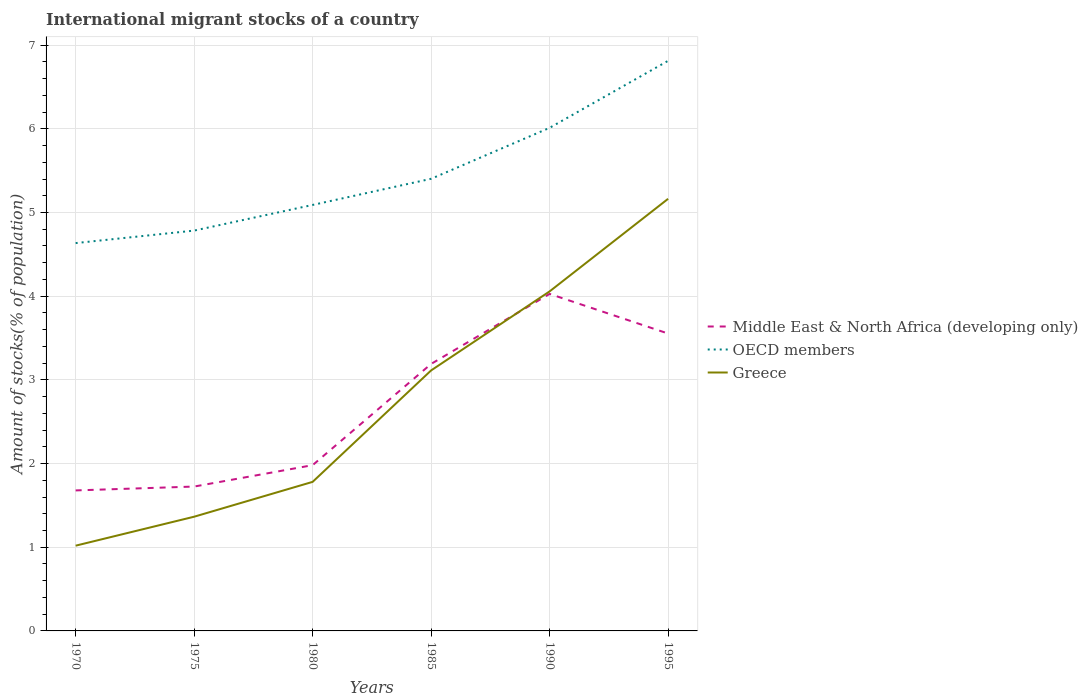Does the line corresponding to OECD members intersect with the line corresponding to Greece?
Your answer should be very brief. No. Is the number of lines equal to the number of legend labels?
Ensure brevity in your answer.  Yes. Across all years, what is the maximum amount of stocks in in OECD members?
Your response must be concise. 4.63. In which year was the amount of stocks in in Middle East & North Africa (developing only) maximum?
Your answer should be compact. 1970. What is the total amount of stocks in in Greece in the graph?
Provide a succinct answer. -0.94. What is the difference between the highest and the second highest amount of stocks in in OECD members?
Provide a succinct answer. 2.18. Is the amount of stocks in in OECD members strictly greater than the amount of stocks in in Middle East & North Africa (developing only) over the years?
Ensure brevity in your answer.  No. Where does the legend appear in the graph?
Provide a short and direct response. Center right. How many legend labels are there?
Your answer should be compact. 3. How are the legend labels stacked?
Provide a succinct answer. Vertical. What is the title of the graph?
Offer a terse response. International migrant stocks of a country. What is the label or title of the X-axis?
Keep it short and to the point. Years. What is the label or title of the Y-axis?
Your response must be concise. Amount of stocks(% of population). What is the Amount of stocks(% of population) in Middle East & North Africa (developing only) in 1970?
Your answer should be compact. 1.68. What is the Amount of stocks(% of population) of OECD members in 1970?
Ensure brevity in your answer.  4.63. What is the Amount of stocks(% of population) in Greece in 1970?
Your response must be concise. 1.02. What is the Amount of stocks(% of population) of Middle East & North Africa (developing only) in 1975?
Your answer should be very brief. 1.73. What is the Amount of stocks(% of population) of OECD members in 1975?
Provide a short and direct response. 4.78. What is the Amount of stocks(% of population) of Greece in 1975?
Offer a very short reply. 1.36. What is the Amount of stocks(% of population) in Middle East & North Africa (developing only) in 1980?
Ensure brevity in your answer.  1.98. What is the Amount of stocks(% of population) in OECD members in 1980?
Your answer should be compact. 5.09. What is the Amount of stocks(% of population) in Greece in 1980?
Keep it short and to the point. 1.78. What is the Amount of stocks(% of population) in Middle East & North Africa (developing only) in 1985?
Keep it short and to the point. 3.19. What is the Amount of stocks(% of population) of OECD members in 1985?
Keep it short and to the point. 5.4. What is the Amount of stocks(% of population) in Greece in 1985?
Offer a terse response. 3.11. What is the Amount of stocks(% of population) in Middle East & North Africa (developing only) in 1990?
Make the answer very short. 4.03. What is the Amount of stocks(% of population) of OECD members in 1990?
Make the answer very short. 6.01. What is the Amount of stocks(% of population) in Greece in 1990?
Ensure brevity in your answer.  4.06. What is the Amount of stocks(% of population) of Middle East & North Africa (developing only) in 1995?
Provide a succinct answer. 3.55. What is the Amount of stocks(% of population) of OECD members in 1995?
Provide a short and direct response. 6.81. What is the Amount of stocks(% of population) in Greece in 1995?
Keep it short and to the point. 5.16. Across all years, what is the maximum Amount of stocks(% of population) in Middle East & North Africa (developing only)?
Offer a terse response. 4.03. Across all years, what is the maximum Amount of stocks(% of population) in OECD members?
Offer a very short reply. 6.81. Across all years, what is the maximum Amount of stocks(% of population) of Greece?
Your answer should be very brief. 5.16. Across all years, what is the minimum Amount of stocks(% of population) of Middle East & North Africa (developing only)?
Your answer should be compact. 1.68. Across all years, what is the minimum Amount of stocks(% of population) of OECD members?
Provide a succinct answer. 4.63. Across all years, what is the minimum Amount of stocks(% of population) in Greece?
Give a very brief answer. 1.02. What is the total Amount of stocks(% of population) of Middle East & North Africa (developing only) in the graph?
Offer a very short reply. 16.16. What is the total Amount of stocks(% of population) of OECD members in the graph?
Offer a very short reply. 32.74. What is the total Amount of stocks(% of population) of Greece in the graph?
Make the answer very short. 16.5. What is the difference between the Amount of stocks(% of population) in Middle East & North Africa (developing only) in 1970 and that in 1975?
Your response must be concise. -0.05. What is the difference between the Amount of stocks(% of population) in OECD members in 1970 and that in 1975?
Your response must be concise. -0.15. What is the difference between the Amount of stocks(% of population) in Greece in 1970 and that in 1975?
Your answer should be compact. -0.35. What is the difference between the Amount of stocks(% of population) of Middle East & North Africa (developing only) in 1970 and that in 1980?
Make the answer very short. -0.3. What is the difference between the Amount of stocks(% of population) in OECD members in 1970 and that in 1980?
Provide a succinct answer. -0.46. What is the difference between the Amount of stocks(% of population) in Greece in 1970 and that in 1980?
Your response must be concise. -0.76. What is the difference between the Amount of stocks(% of population) of Middle East & North Africa (developing only) in 1970 and that in 1985?
Provide a succinct answer. -1.51. What is the difference between the Amount of stocks(% of population) in OECD members in 1970 and that in 1985?
Your response must be concise. -0.77. What is the difference between the Amount of stocks(% of population) in Greece in 1970 and that in 1985?
Your answer should be very brief. -2.09. What is the difference between the Amount of stocks(% of population) in Middle East & North Africa (developing only) in 1970 and that in 1990?
Offer a terse response. -2.35. What is the difference between the Amount of stocks(% of population) in OECD members in 1970 and that in 1990?
Your answer should be very brief. -1.38. What is the difference between the Amount of stocks(% of population) in Greece in 1970 and that in 1990?
Keep it short and to the point. -3.04. What is the difference between the Amount of stocks(% of population) in Middle East & North Africa (developing only) in 1970 and that in 1995?
Keep it short and to the point. -1.87. What is the difference between the Amount of stocks(% of population) in OECD members in 1970 and that in 1995?
Offer a very short reply. -2.18. What is the difference between the Amount of stocks(% of population) of Greece in 1970 and that in 1995?
Give a very brief answer. -4.14. What is the difference between the Amount of stocks(% of population) of Middle East & North Africa (developing only) in 1975 and that in 1980?
Make the answer very short. -0.26. What is the difference between the Amount of stocks(% of population) of OECD members in 1975 and that in 1980?
Provide a short and direct response. -0.31. What is the difference between the Amount of stocks(% of population) of Greece in 1975 and that in 1980?
Your answer should be very brief. -0.42. What is the difference between the Amount of stocks(% of population) in Middle East & North Africa (developing only) in 1975 and that in 1985?
Keep it short and to the point. -1.47. What is the difference between the Amount of stocks(% of population) of OECD members in 1975 and that in 1985?
Keep it short and to the point. -0.62. What is the difference between the Amount of stocks(% of population) of Greece in 1975 and that in 1985?
Make the answer very short. -1.75. What is the difference between the Amount of stocks(% of population) in Middle East & North Africa (developing only) in 1975 and that in 1990?
Your answer should be very brief. -2.3. What is the difference between the Amount of stocks(% of population) in OECD members in 1975 and that in 1990?
Offer a terse response. -1.23. What is the difference between the Amount of stocks(% of population) of Greece in 1975 and that in 1990?
Offer a very short reply. -2.69. What is the difference between the Amount of stocks(% of population) of Middle East & North Africa (developing only) in 1975 and that in 1995?
Give a very brief answer. -1.83. What is the difference between the Amount of stocks(% of population) in OECD members in 1975 and that in 1995?
Your response must be concise. -2.03. What is the difference between the Amount of stocks(% of population) of Greece in 1975 and that in 1995?
Keep it short and to the point. -3.8. What is the difference between the Amount of stocks(% of population) in Middle East & North Africa (developing only) in 1980 and that in 1985?
Provide a succinct answer. -1.21. What is the difference between the Amount of stocks(% of population) in OECD members in 1980 and that in 1985?
Provide a short and direct response. -0.31. What is the difference between the Amount of stocks(% of population) of Greece in 1980 and that in 1985?
Provide a short and direct response. -1.33. What is the difference between the Amount of stocks(% of population) in Middle East & North Africa (developing only) in 1980 and that in 1990?
Provide a succinct answer. -2.05. What is the difference between the Amount of stocks(% of population) of OECD members in 1980 and that in 1990?
Your answer should be very brief. -0.92. What is the difference between the Amount of stocks(% of population) in Greece in 1980 and that in 1990?
Give a very brief answer. -2.28. What is the difference between the Amount of stocks(% of population) of Middle East & North Africa (developing only) in 1980 and that in 1995?
Provide a short and direct response. -1.57. What is the difference between the Amount of stocks(% of population) in OECD members in 1980 and that in 1995?
Offer a terse response. -1.72. What is the difference between the Amount of stocks(% of population) of Greece in 1980 and that in 1995?
Your answer should be very brief. -3.38. What is the difference between the Amount of stocks(% of population) of Middle East & North Africa (developing only) in 1985 and that in 1990?
Give a very brief answer. -0.84. What is the difference between the Amount of stocks(% of population) in OECD members in 1985 and that in 1990?
Keep it short and to the point. -0.61. What is the difference between the Amount of stocks(% of population) in Greece in 1985 and that in 1990?
Provide a short and direct response. -0.94. What is the difference between the Amount of stocks(% of population) in Middle East & North Africa (developing only) in 1985 and that in 1995?
Your answer should be compact. -0.36. What is the difference between the Amount of stocks(% of population) of OECD members in 1985 and that in 1995?
Your answer should be very brief. -1.41. What is the difference between the Amount of stocks(% of population) in Greece in 1985 and that in 1995?
Provide a short and direct response. -2.05. What is the difference between the Amount of stocks(% of population) in Middle East & North Africa (developing only) in 1990 and that in 1995?
Provide a short and direct response. 0.47. What is the difference between the Amount of stocks(% of population) in OECD members in 1990 and that in 1995?
Offer a very short reply. -0.8. What is the difference between the Amount of stocks(% of population) in Greece in 1990 and that in 1995?
Your answer should be compact. -1.11. What is the difference between the Amount of stocks(% of population) of Middle East & North Africa (developing only) in 1970 and the Amount of stocks(% of population) of OECD members in 1975?
Ensure brevity in your answer.  -3.1. What is the difference between the Amount of stocks(% of population) of Middle East & North Africa (developing only) in 1970 and the Amount of stocks(% of population) of Greece in 1975?
Offer a terse response. 0.31. What is the difference between the Amount of stocks(% of population) in OECD members in 1970 and the Amount of stocks(% of population) in Greece in 1975?
Your response must be concise. 3.27. What is the difference between the Amount of stocks(% of population) of Middle East & North Africa (developing only) in 1970 and the Amount of stocks(% of population) of OECD members in 1980?
Make the answer very short. -3.41. What is the difference between the Amount of stocks(% of population) of Middle East & North Africa (developing only) in 1970 and the Amount of stocks(% of population) of Greece in 1980?
Give a very brief answer. -0.1. What is the difference between the Amount of stocks(% of population) in OECD members in 1970 and the Amount of stocks(% of population) in Greece in 1980?
Keep it short and to the point. 2.85. What is the difference between the Amount of stocks(% of population) in Middle East & North Africa (developing only) in 1970 and the Amount of stocks(% of population) in OECD members in 1985?
Keep it short and to the point. -3.72. What is the difference between the Amount of stocks(% of population) of Middle East & North Africa (developing only) in 1970 and the Amount of stocks(% of population) of Greece in 1985?
Offer a very short reply. -1.43. What is the difference between the Amount of stocks(% of population) in OECD members in 1970 and the Amount of stocks(% of population) in Greece in 1985?
Provide a short and direct response. 1.52. What is the difference between the Amount of stocks(% of population) of Middle East & North Africa (developing only) in 1970 and the Amount of stocks(% of population) of OECD members in 1990?
Your answer should be very brief. -4.33. What is the difference between the Amount of stocks(% of population) in Middle East & North Africa (developing only) in 1970 and the Amount of stocks(% of population) in Greece in 1990?
Keep it short and to the point. -2.38. What is the difference between the Amount of stocks(% of population) in OECD members in 1970 and the Amount of stocks(% of population) in Greece in 1990?
Give a very brief answer. 0.58. What is the difference between the Amount of stocks(% of population) of Middle East & North Africa (developing only) in 1970 and the Amount of stocks(% of population) of OECD members in 1995?
Make the answer very short. -5.13. What is the difference between the Amount of stocks(% of population) in Middle East & North Africa (developing only) in 1970 and the Amount of stocks(% of population) in Greece in 1995?
Make the answer very short. -3.48. What is the difference between the Amount of stocks(% of population) in OECD members in 1970 and the Amount of stocks(% of population) in Greece in 1995?
Make the answer very short. -0.53. What is the difference between the Amount of stocks(% of population) of Middle East & North Africa (developing only) in 1975 and the Amount of stocks(% of population) of OECD members in 1980?
Your answer should be very brief. -3.37. What is the difference between the Amount of stocks(% of population) in Middle East & North Africa (developing only) in 1975 and the Amount of stocks(% of population) in Greece in 1980?
Keep it short and to the point. -0.06. What is the difference between the Amount of stocks(% of population) of OECD members in 1975 and the Amount of stocks(% of population) of Greece in 1980?
Your response must be concise. 3. What is the difference between the Amount of stocks(% of population) in Middle East & North Africa (developing only) in 1975 and the Amount of stocks(% of population) in OECD members in 1985?
Give a very brief answer. -3.68. What is the difference between the Amount of stocks(% of population) in Middle East & North Africa (developing only) in 1975 and the Amount of stocks(% of population) in Greece in 1985?
Provide a short and direct response. -1.39. What is the difference between the Amount of stocks(% of population) of OECD members in 1975 and the Amount of stocks(% of population) of Greece in 1985?
Your answer should be very brief. 1.67. What is the difference between the Amount of stocks(% of population) of Middle East & North Africa (developing only) in 1975 and the Amount of stocks(% of population) of OECD members in 1990?
Your answer should be compact. -4.29. What is the difference between the Amount of stocks(% of population) of Middle East & North Africa (developing only) in 1975 and the Amount of stocks(% of population) of Greece in 1990?
Offer a very short reply. -2.33. What is the difference between the Amount of stocks(% of population) in OECD members in 1975 and the Amount of stocks(% of population) in Greece in 1990?
Ensure brevity in your answer.  0.73. What is the difference between the Amount of stocks(% of population) of Middle East & North Africa (developing only) in 1975 and the Amount of stocks(% of population) of OECD members in 1995?
Give a very brief answer. -5.09. What is the difference between the Amount of stocks(% of population) of Middle East & North Africa (developing only) in 1975 and the Amount of stocks(% of population) of Greece in 1995?
Provide a succinct answer. -3.44. What is the difference between the Amount of stocks(% of population) in OECD members in 1975 and the Amount of stocks(% of population) in Greece in 1995?
Ensure brevity in your answer.  -0.38. What is the difference between the Amount of stocks(% of population) in Middle East & North Africa (developing only) in 1980 and the Amount of stocks(% of population) in OECD members in 1985?
Provide a short and direct response. -3.42. What is the difference between the Amount of stocks(% of population) in Middle East & North Africa (developing only) in 1980 and the Amount of stocks(% of population) in Greece in 1985?
Your response must be concise. -1.13. What is the difference between the Amount of stocks(% of population) in OECD members in 1980 and the Amount of stocks(% of population) in Greece in 1985?
Your answer should be compact. 1.98. What is the difference between the Amount of stocks(% of population) in Middle East & North Africa (developing only) in 1980 and the Amount of stocks(% of population) in OECD members in 1990?
Give a very brief answer. -4.03. What is the difference between the Amount of stocks(% of population) in Middle East & North Africa (developing only) in 1980 and the Amount of stocks(% of population) in Greece in 1990?
Keep it short and to the point. -2.08. What is the difference between the Amount of stocks(% of population) in OECD members in 1980 and the Amount of stocks(% of population) in Greece in 1990?
Provide a short and direct response. 1.03. What is the difference between the Amount of stocks(% of population) of Middle East & North Africa (developing only) in 1980 and the Amount of stocks(% of population) of OECD members in 1995?
Your answer should be very brief. -4.83. What is the difference between the Amount of stocks(% of population) in Middle East & North Africa (developing only) in 1980 and the Amount of stocks(% of population) in Greece in 1995?
Offer a terse response. -3.18. What is the difference between the Amount of stocks(% of population) in OECD members in 1980 and the Amount of stocks(% of population) in Greece in 1995?
Provide a succinct answer. -0.07. What is the difference between the Amount of stocks(% of population) in Middle East & North Africa (developing only) in 1985 and the Amount of stocks(% of population) in OECD members in 1990?
Your answer should be compact. -2.82. What is the difference between the Amount of stocks(% of population) of Middle East & North Africa (developing only) in 1985 and the Amount of stocks(% of population) of Greece in 1990?
Your response must be concise. -0.87. What is the difference between the Amount of stocks(% of population) in OECD members in 1985 and the Amount of stocks(% of population) in Greece in 1990?
Your answer should be compact. 1.35. What is the difference between the Amount of stocks(% of population) in Middle East & North Africa (developing only) in 1985 and the Amount of stocks(% of population) in OECD members in 1995?
Your response must be concise. -3.62. What is the difference between the Amount of stocks(% of population) in Middle East & North Africa (developing only) in 1985 and the Amount of stocks(% of population) in Greece in 1995?
Offer a terse response. -1.97. What is the difference between the Amount of stocks(% of population) of OECD members in 1985 and the Amount of stocks(% of population) of Greece in 1995?
Your response must be concise. 0.24. What is the difference between the Amount of stocks(% of population) of Middle East & North Africa (developing only) in 1990 and the Amount of stocks(% of population) of OECD members in 1995?
Keep it short and to the point. -2.79. What is the difference between the Amount of stocks(% of population) of Middle East & North Africa (developing only) in 1990 and the Amount of stocks(% of population) of Greece in 1995?
Your answer should be very brief. -1.14. What is the difference between the Amount of stocks(% of population) of OECD members in 1990 and the Amount of stocks(% of population) of Greece in 1995?
Your answer should be very brief. 0.85. What is the average Amount of stocks(% of population) of Middle East & North Africa (developing only) per year?
Offer a very short reply. 2.69. What is the average Amount of stocks(% of population) in OECD members per year?
Keep it short and to the point. 5.46. What is the average Amount of stocks(% of population) in Greece per year?
Provide a short and direct response. 2.75. In the year 1970, what is the difference between the Amount of stocks(% of population) in Middle East & North Africa (developing only) and Amount of stocks(% of population) in OECD members?
Your answer should be very brief. -2.96. In the year 1970, what is the difference between the Amount of stocks(% of population) in Middle East & North Africa (developing only) and Amount of stocks(% of population) in Greece?
Offer a very short reply. 0.66. In the year 1970, what is the difference between the Amount of stocks(% of population) of OECD members and Amount of stocks(% of population) of Greece?
Offer a very short reply. 3.62. In the year 1975, what is the difference between the Amount of stocks(% of population) of Middle East & North Africa (developing only) and Amount of stocks(% of population) of OECD members?
Ensure brevity in your answer.  -3.06. In the year 1975, what is the difference between the Amount of stocks(% of population) in Middle East & North Africa (developing only) and Amount of stocks(% of population) in Greece?
Your answer should be very brief. 0.36. In the year 1975, what is the difference between the Amount of stocks(% of population) in OECD members and Amount of stocks(% of population) in Greece?
Make the answer very short. 3.42. In the year 1980, what is the difference between the Amount of stocks(% of population) of Middle East & North Africa (developing only) and Amount of stocks(% of population) of OECD members?
Your response must be concise. -3.11. In the year 1980, what is the difference between the Amount of stocks(% of population) in Middle East & North Africa (developing only) and Amount of stocks(% of population) in Greece?
Your response must be concise. 0.2. In the year 1980, what is the difference between the Amount of stocks(% of population) in OECD members and Amount of stocks(% of population) in Greece?
Provide a succinct answer. 3.31. In the year 1985, what is the difference between the Amount of stocks(% of population) of Middle East & North Africa (developing only) and Amount of stocks(% of population) of OECD members?
Your answer should be very brief. -2.21. In the year 1985, what is the difference between the Amount of stocks(% of population) in Middle East & North Africa (developing only) and Amount of stocks(% of population) in Greece?
Keep it short and to the point. 0.08. In the year 1985, what is the difference between the Amount of stocks(% of population) in OECD members and Amount of stocks(% of population) in Greece?
Provide a short and direct response. 2.29. In the year 1990, what is the difference between the Amount of stocks(% of population) in Middle East & North Africa (developing only) and Amount of stocks(% of population) in OECD members?
Provide a succinct answer. -1.98. In the year 1990, what is the difference between the Amount of stocks(% of population) in Middle East & North Africa (developing only) and Amount of stocks(% of population) in Greece?
Give a very brief answer. -0.03. In the year 1990, what is the difference between the Amount of stocks(% of population) in OECD members and Amount of stocks(% of population) in Greece?
Your response must be concise. 1.95. In the year 1995, what is the difference between the Amount of stocks(% of population) of Middle East & North Africa (developing only) and Amount of stocks(% of population) of OECD members?
Offer a very short reply. -3.26. In the year 1995, what is the difference between the Amount of stocks(% of population) in Middle East & North Africa (developing only) and Amount of stocks(% of population) in Greece?
Your answer should be compact. -1.61. In the year 1995, what is the difference between the Amount of stocks(% of population) of OECD members and Amount of stocks(% of population) of Greece?
Offer a terse response. 1.65. What is the ratio of the Amount of stocks(% of population) in Middle East & North Africa (developing only) in 1970 to that in 1975?
Your response must be concise. 0.97. What is the ratio of the Amount of stocks(% of population) in OECD members in 1970 to that in 1975?
Offer a terse response. 0.97. What is the ratio of the Amount of stocks(% of population) of Greece in 1970 to that in 1975?
Your answer should be very brief. 0.75. What is the ratio of the Amount of stocks(% of population) of Middle East & North Africa (developing only) in 1970 to that in 1980?
Offer a very short reply. 0.85. What is the ratio of the Amount of stocks(% of population) in OECD members in 1970 to that in 1980?
Make the answer very short. 0.91. What is the ratio of the Amount of stocks(% of population) of Greece in 1970 to that in 1980?
Provide a short and direct response. 0.57. What is the ratio of the Amount of stocks(% of population) in Middle East & North Africa (developing only) in 1970 to that in 1985?
Ensure brevity in your answer.  0.53. What is the ratio of the Amount of stocks(% of population) of OECD members in 1970 to that in 1985?
Your response must be concise. 0.86. What is the ratio of the Amount of stocks(% of population) of Greece in 1970 to that in 1985?
Provide a short and direct response. 0.33. What is the ratio of the Amount of stocks(% of population) in Middle East & North Africa (developing only) in 1970 to that in 1990?
Your answer should be compact. 0.42. What is the ratio of the Amount of stocks(% of population) of OECD members in 1970 to that in 1990?
Provide a short and direct response. 0.77. What is the ratio of the Amount of stocks(% of population) in Greece in 1970 to that in 1990?
Offer a terse response. 0.25. What is the ratio of the Amount of stocks(% of population) of Middle East & North Africa (developing only) in 1970 to that in 1995?
Provide a short and direct response. 0.47. What is the ratio of the Amount of stocks(% of population) of OECD members in 1970 to that in 1995?
Make the answer very short. 0.68. What is the ratio of the Amount of stocks(% of population) in Greece in 1970 to that in 1995?
Your response must be concise. 0.2. What is the ratio of the Amount of stocks(% of population) in Middle East & North Africa (developing only) in 1975 to that in 1980?
Ensure brevity in your answer.  0.87. What is the ratio of the Amount of stocks(% of population) of OECD members in 1975 to that in 1980?
Keep it short and to the point. 0.94. What is the ratio of the Amount of stocks(% of population) in Greece in 1975 to that in 1980?
Keep it short and to the point. 0.77. What is the ratio of the Amount of stocks(% of population) in Middle East & North Africa (developing only) in 1975 to that in 1985?
Ensure brevity in your answer.  0.54. What is the ratio of the Amount of stocks(% of population) of OECD members in 1975 to that in 1985?
Make the answer very short. 0.89. What is the ratio of the Amount of stocks(% of population) of Greece in 1975 to that in 1985?
Provide a succinct answer. 0.44. What is the ratio of the Amount of stocks(% of population) of Middle East & North Africa (developing only) in 1975 to that in 1990?
Provide a short and direct response. 0.43. What is the ratio of the Amount of stocks(% of population) of OECD members in 1975 to that in 1990?
Keep it short and to the point. 0.8. What is the ratio of the Amount of stocks(% of population) of Greece in 1975 to that in 1990?
Make the answer very short. 0.34. What is the ratio of the Amount of stocks(% of population) of Middle East & North Africa (developing only) in 1975 to that in 1995?
Your answer should be very brief. 0.49. What is the ratio of the Amount of stocks(% of population) in OECD members in 1975 to that in 1995?
Make the answer very short. 0.7. What is the ratio of the Amount of stocks(% of population) in Greece in 1975 to that in 1995?
Give a very brief answer. 0.26. What is the ratio of the Amount of stocks(% of population) of Middle East & North Africa (developing only) in 1980 to that in 1985?
Your answer should be very brief. 0.62. What is the ratio of the Amount of stocks(% of population) of OECD members in 1980 to that in 1985?
Make the answer very short. 0.94. What is the ratio of the Amount of stocks(% of population) in Greece in 1980 to that in 1985?
Provide a succinct answer. 0.57. What is the ratio of the Amount of stocks(% of population) of Middle East & North Africa (developing only) in 1980 to that in 1990?
Keep it short and to the point. 0.49. What is the ratio of the Amount of stocks(% of population) of OECD members in 1980 to that in 1990?
Your response must be concise. 0.85. What is the ratio of the Amount of stocks(% of population) in Greece in 1980 to that in 1990?
Your answer should be compact. 0.44. What is the ratio of the Amount of stocks(% of population) in Middle East & North Africa (developing only) in 1980 to that in 1995?
Your answer should be compact. 0.56. What is the ratio of the Amount of stocks(% of population) in OECD members in 1980 to that in 1995?
Your response must be concise. 0.75. What is the ratio of the Amount of stocks(% of population) of Greece in 1980 to that in 1995?
Provide a succinct answer. 0.34. What is the ratio of the Amount of stocks(% of population) in Middle East & North Africa (developing only) in 1985 to that in 1990?
Give a very brief answer. 0.79. What is the ratio of the Amount of stocks(% of population) in OECD members in 1985 to that in 1990?
Offer a very short reply. 0.9. What is the ratio of the Amount of stocks(% of population) in Greece in 1985 to that in 1990?
Your answer should be very brief. 0.77. What is the ratio of the Amount of stocks(% of population) in Middle East & North Africa (developing only) in 1985 to that in 1995?
Provide a succinct answer. 0.9. What is the ratio of the Amount of stocks(% of population) in OECD members in 1985 to that in 1995?
Provide a succinct answer. 0.79. What is the ratio of the Amount of stocks(% of population) of Greece in 1985 to that in 1995?
Ensure brevity in your answer.  0.6. What is the ratio of the Amount of stocks(% of population) of Middle East & North Africa (developing only) in 1990 to that in 1995?
Your answer should be compact. 1.13. What is the ratio of the Amount of stocks(% of population) of OECD members in 1990 to that in 1995?
Your answer should be compact. 0.88. What is the ratio of the Amount of stocks(% of population) of Greece in 1990 to that in 1995?
Provide a succinct answer. 0.79. What is the difference between the highest and the second highest Amount of stocks(% of population) of Middle East & North Africa (developing only)?
Your answer should be compact. 0.47. What is the difference between the highest and the second highest Amount of stocks(% of population) of OECD members?
Provide a succinct answer. 0.8. What is the difference between the highest and the second highest Amount of stocks(% of population) of Greece?
Make the answer very short. 1.11. What is the difference between the highest and the lowest Amount of stocks(% of population) in Middle East & North Africa (developing only)?
Ensure brevity in your answer.  2.35. What is the difference between the highest and the lowest Amount of stocks(% of population) in OECD members?
Provide a short and direct response. 2.18. What is the difference between the highest and the lowest Amount of stocks(% of population) of Greece?
Give a very brief answer. 4.14. 